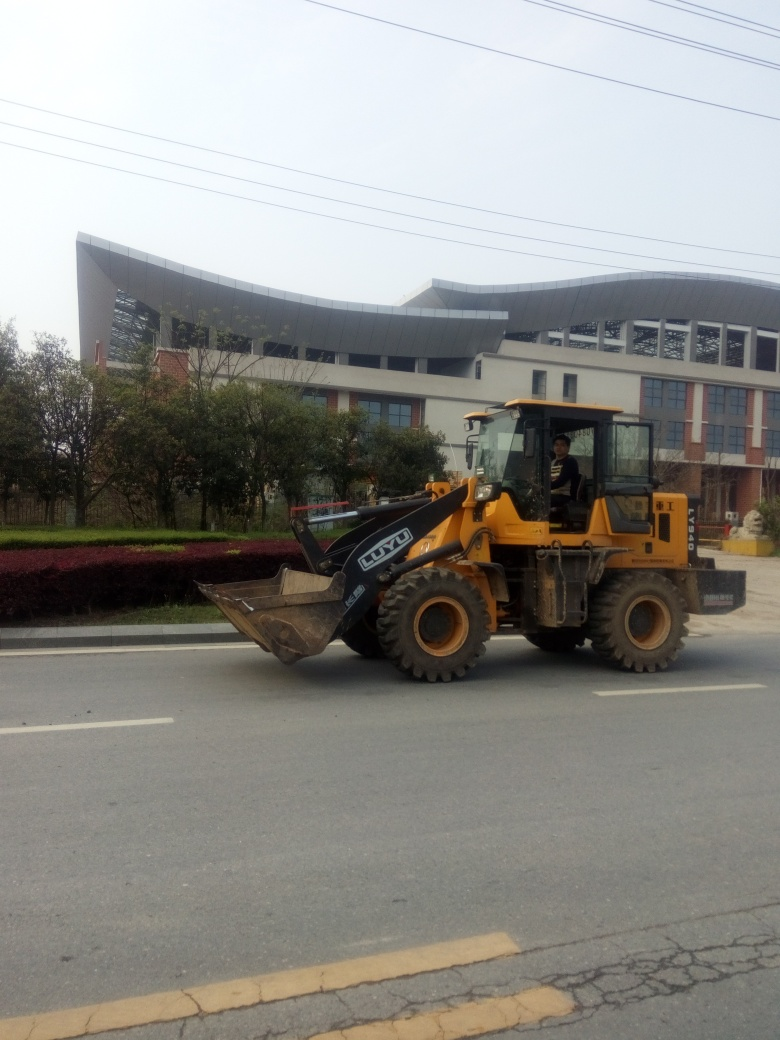Is the background clear?
A. Obstructed background
B. Relatively clear
C. Completely blurred background
Answer with the option's letter from the given choices directly. B. The background is relatively clear. Details of the building, trees, and power lines are distinguishable, though the focus is on the front loader occupying the foreground. 